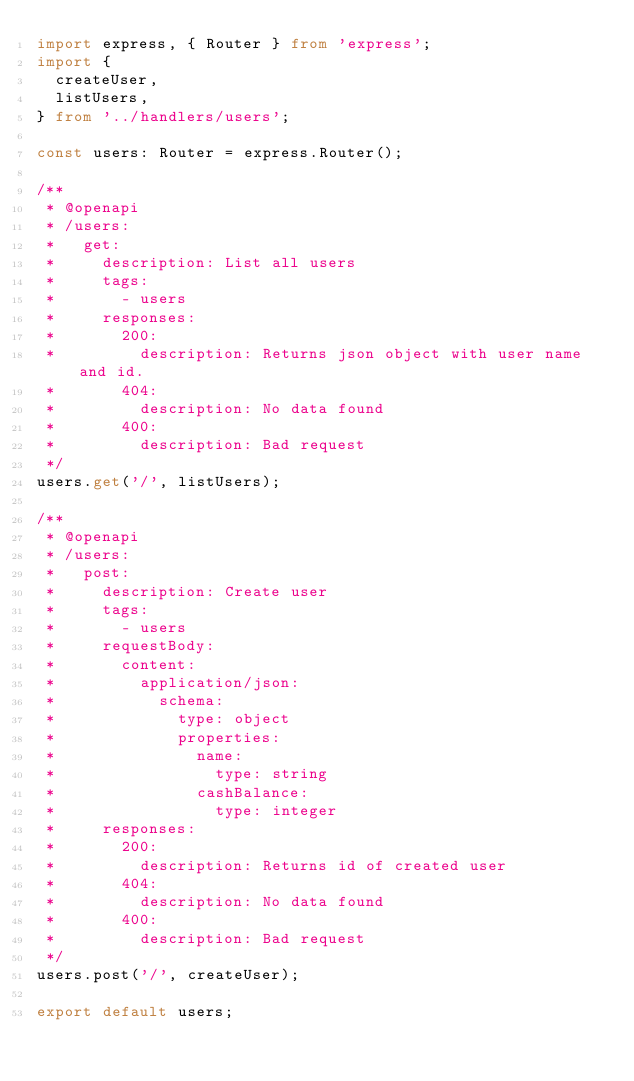Convert code to text. <code><loc_0><loc_0><loc_500><loc_500><_TypeScript_>import express, { Router } from 'express';
import {
  createUser,
  listUsers,
} from '../handlers/users';

const users: Router = express.Router();

/**
 * @openapi
 * /users:
 *   get:
 *     description: List all users
 *     tags:
 *       - users
 *     responses:
 *       200:
 *         description: Returns json object with user name and id.
 *       404:
 *         description: No data found
 *       400:
 *         description: Bad request
 */
users.get('/', listUsers);

/**
 * @openapi
 * /users:
 *   post:
 *     description: Create user
 *     tags:
 *       - users
 *     requestBody:
 *       content:
 *         application/json:
 *           schema:
 *             type: object
 *             properties:
 *               name:
 *                 type: string
 *               cashBalance:
 *                 type: integer
 *     responses:
 *       200:
 *         description: Returns id of created user
 *       404:
 *         description: No data found
 *       400:
 *         description: Bad request
 */
users.post('/', createUser);

export default users;
</code> 